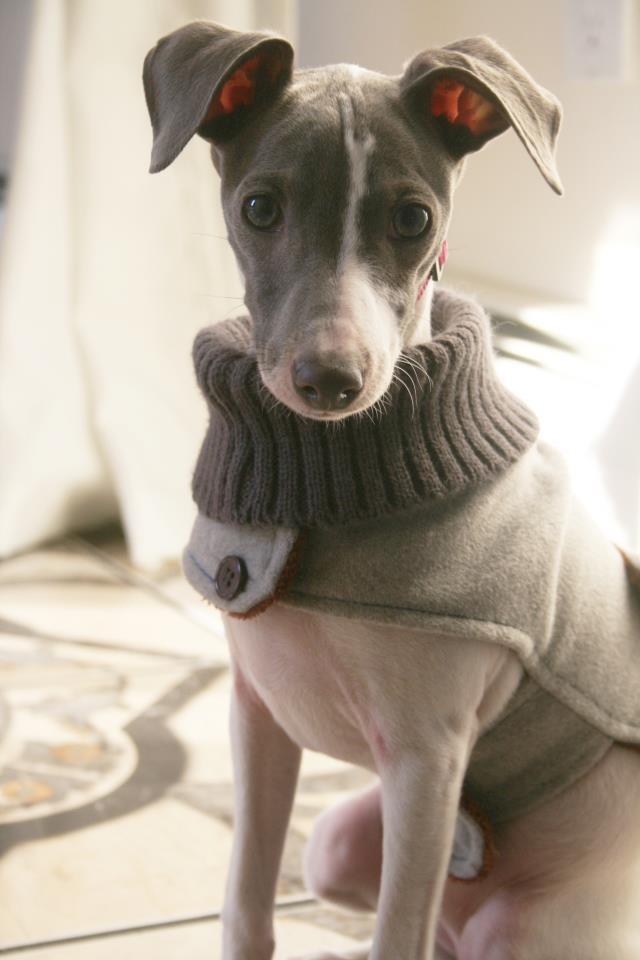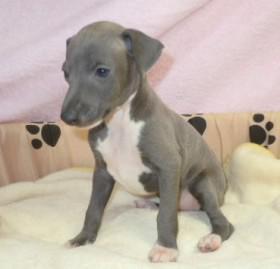The first image is the image on the left, the second image is the image on the right. Evaluate the accuracy of this statement regarding the images: "In the left image, there's an Italian Greyhound wearing a sweater and sitting.". Is it true? Answer yes or no. Yes. The first image is the image on the left, the second image is the image on the right. Analyze the images presented: Is the assertion "At least one dog is sitting." valid? Answer yes or no. Yes. 